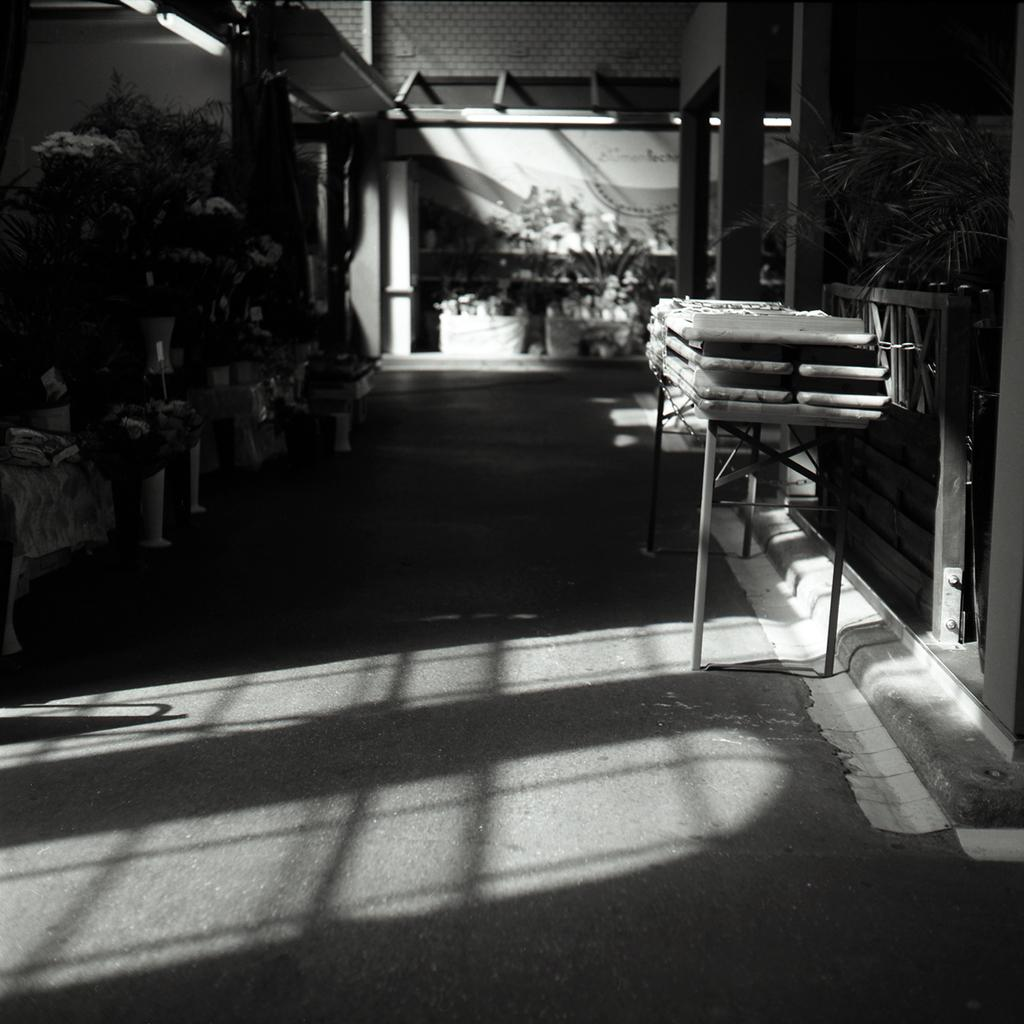What is the color scheme of the image? The image is black and white. What type of furniture is present in the image? There is a table in the image. What objects are used for planting in the image? There are flower pots in the image. What type of vegetation is present in the image? There are plants in the image. What architectural feature is visible in the image? A fence is visible in the image. What type of structure is visible in the image? A wall is visible in the image. What type of surface is at the bottom of the image? There is a road at the bottom of the image. What type of apparatus is used by the mom to peel the banana in the image? There is no apparatus, mom, or banana present in the image. 